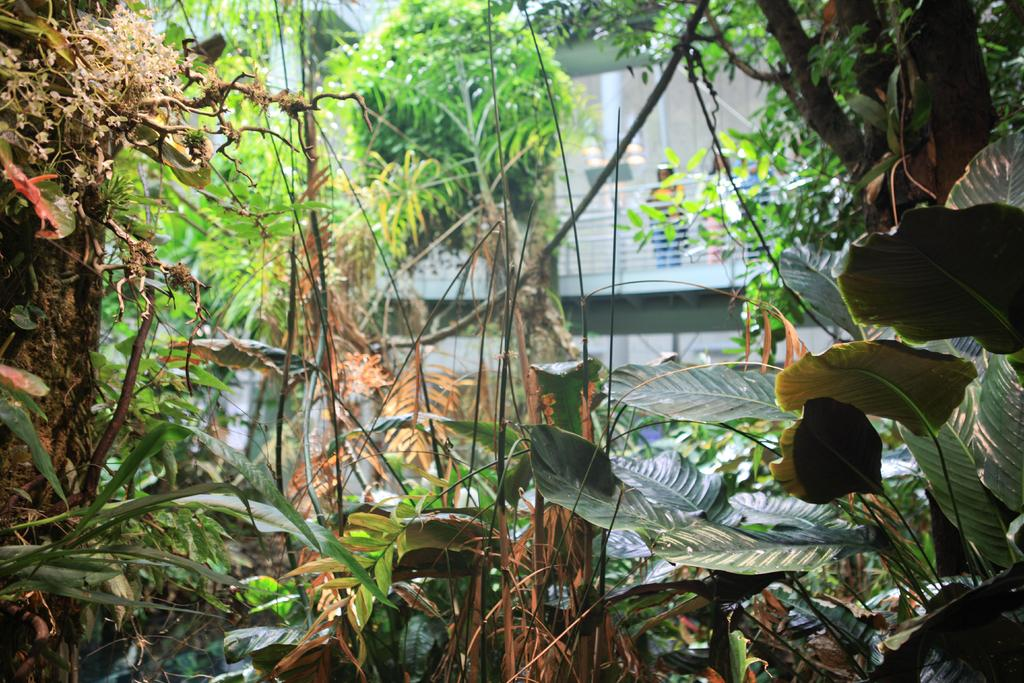What type of natural elements can be seen in the image? There are trees in the image. What can be seen in the distance in the image? There is a building in the background of the image. Are there any human figures present in the image? Yes, there are people standing in the background of the image. What color are the toes of the person in the image? There are no visible toes in the image, as the people are standing in the background and not close enough for their toes to be seen. 